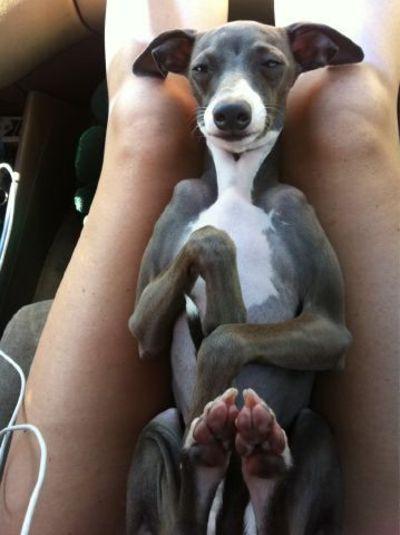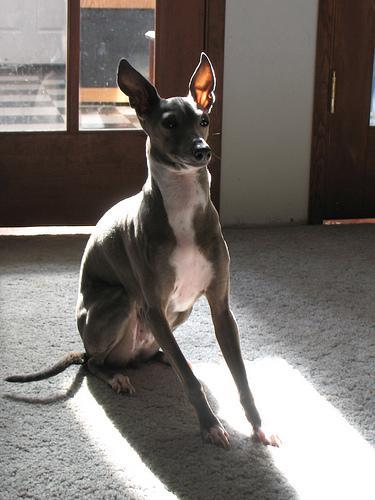The first image is the image on the left, the second image is the image on the right. For the images shown, is this caption "Two dogs are near each other and 1 of them has its teeth showing." true? Answer yes or no. No. The first image is the image on the left, the second image is the image on the right. Analyze the images presented: Is the assertion "a dog has it's tongue sticking out" valid? Answer yes or no. No. 